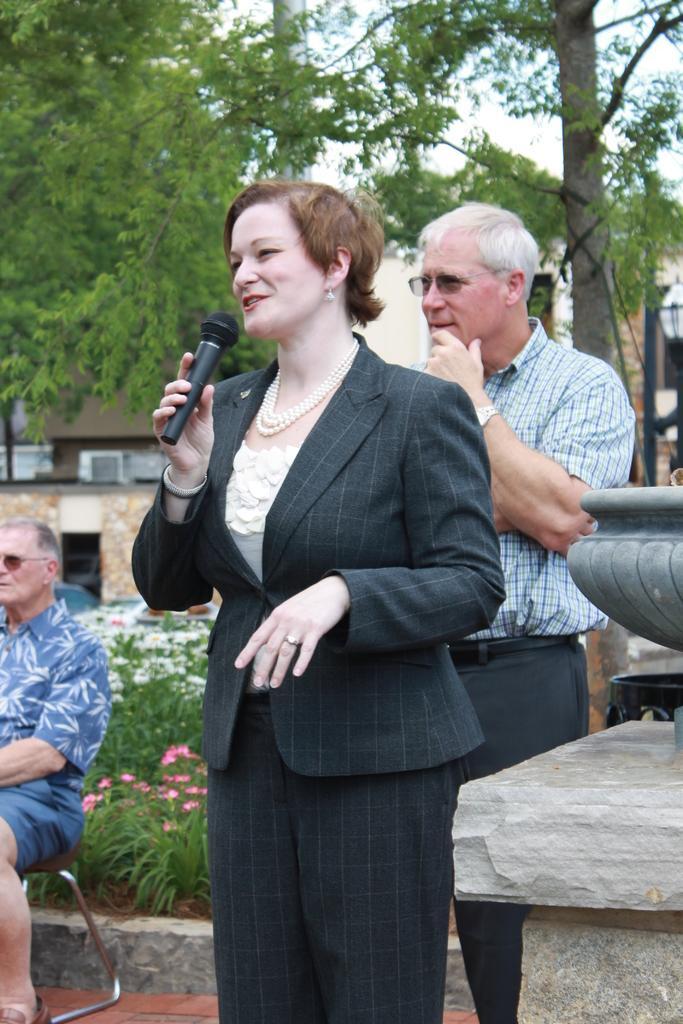Describe this image in one or two sentences. In this picture we have a woman speaking and smiling, she is holding a microphone in her right hand. There is a person behind her, he is standing and smiling. 